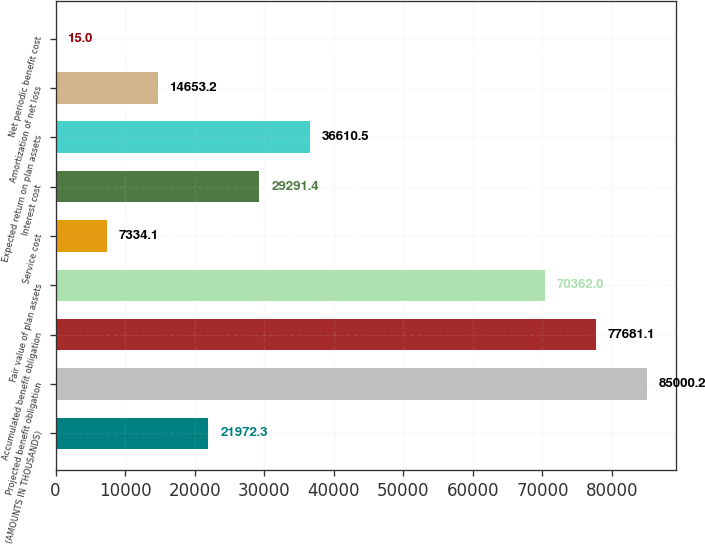Convert chart. <chart><loc_0><loc_0><loc_500><loc_500><bar_chart><fcel>(AMOUNTS IN THOUSANDS)<fcel>Projected benefit obligation<fcel>Accumulated benefit obligation<fcel>Fair value of plan assets<fcel>Service cost<fcel>Interest cost<fcel>Expected return on plan assets<fcel>Amortization of net loss<fcel>Net periodic benefit cost<nl><fcel>21972.3<fcel>85000.2<fcel>77681.1<fcel>70362<fcel>7334.1<fcel>29291.4<fcel>36610.5<fcel>14653.2<fcel>15<nl></chart> 